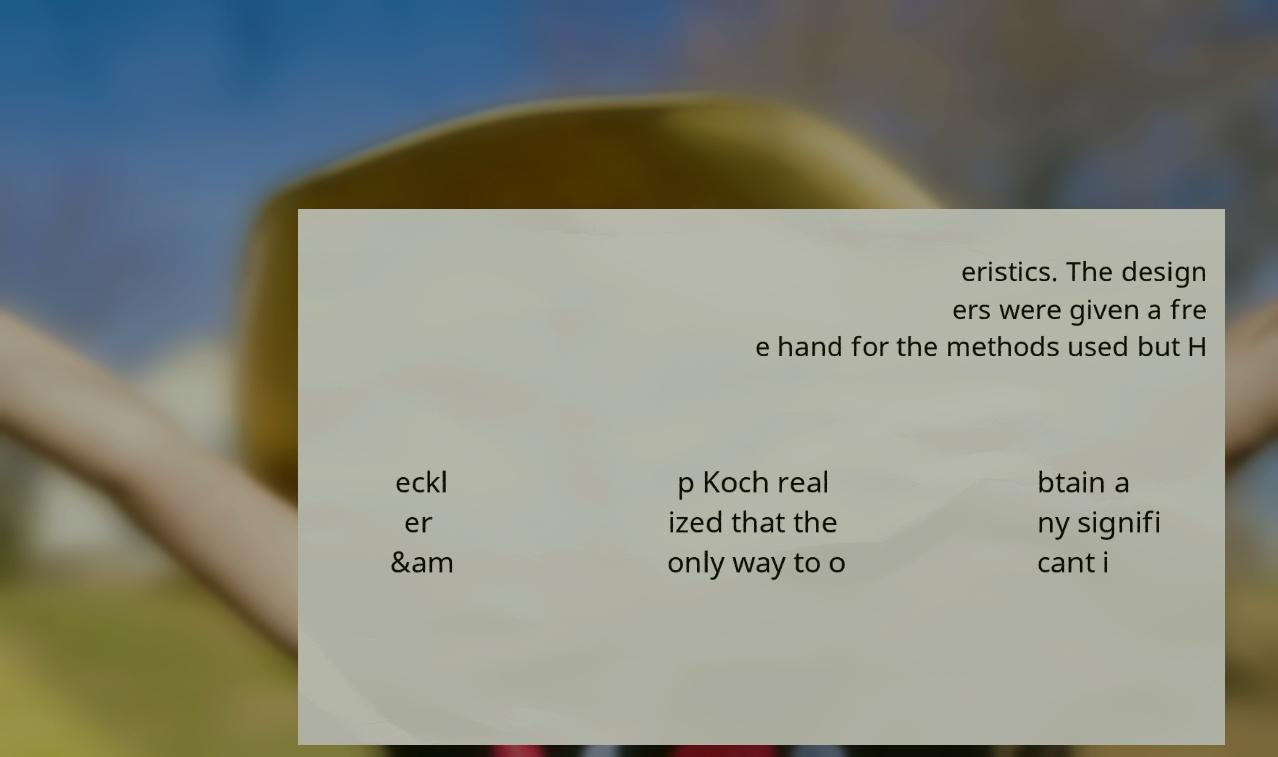What messages or text are displayed in this image? I need them in a readable, typed format. eristics. The design ers were given a fre e hand for the methods used but H eckl er &am p Koch real ized that the only way to o btain a ny signifi cant i 